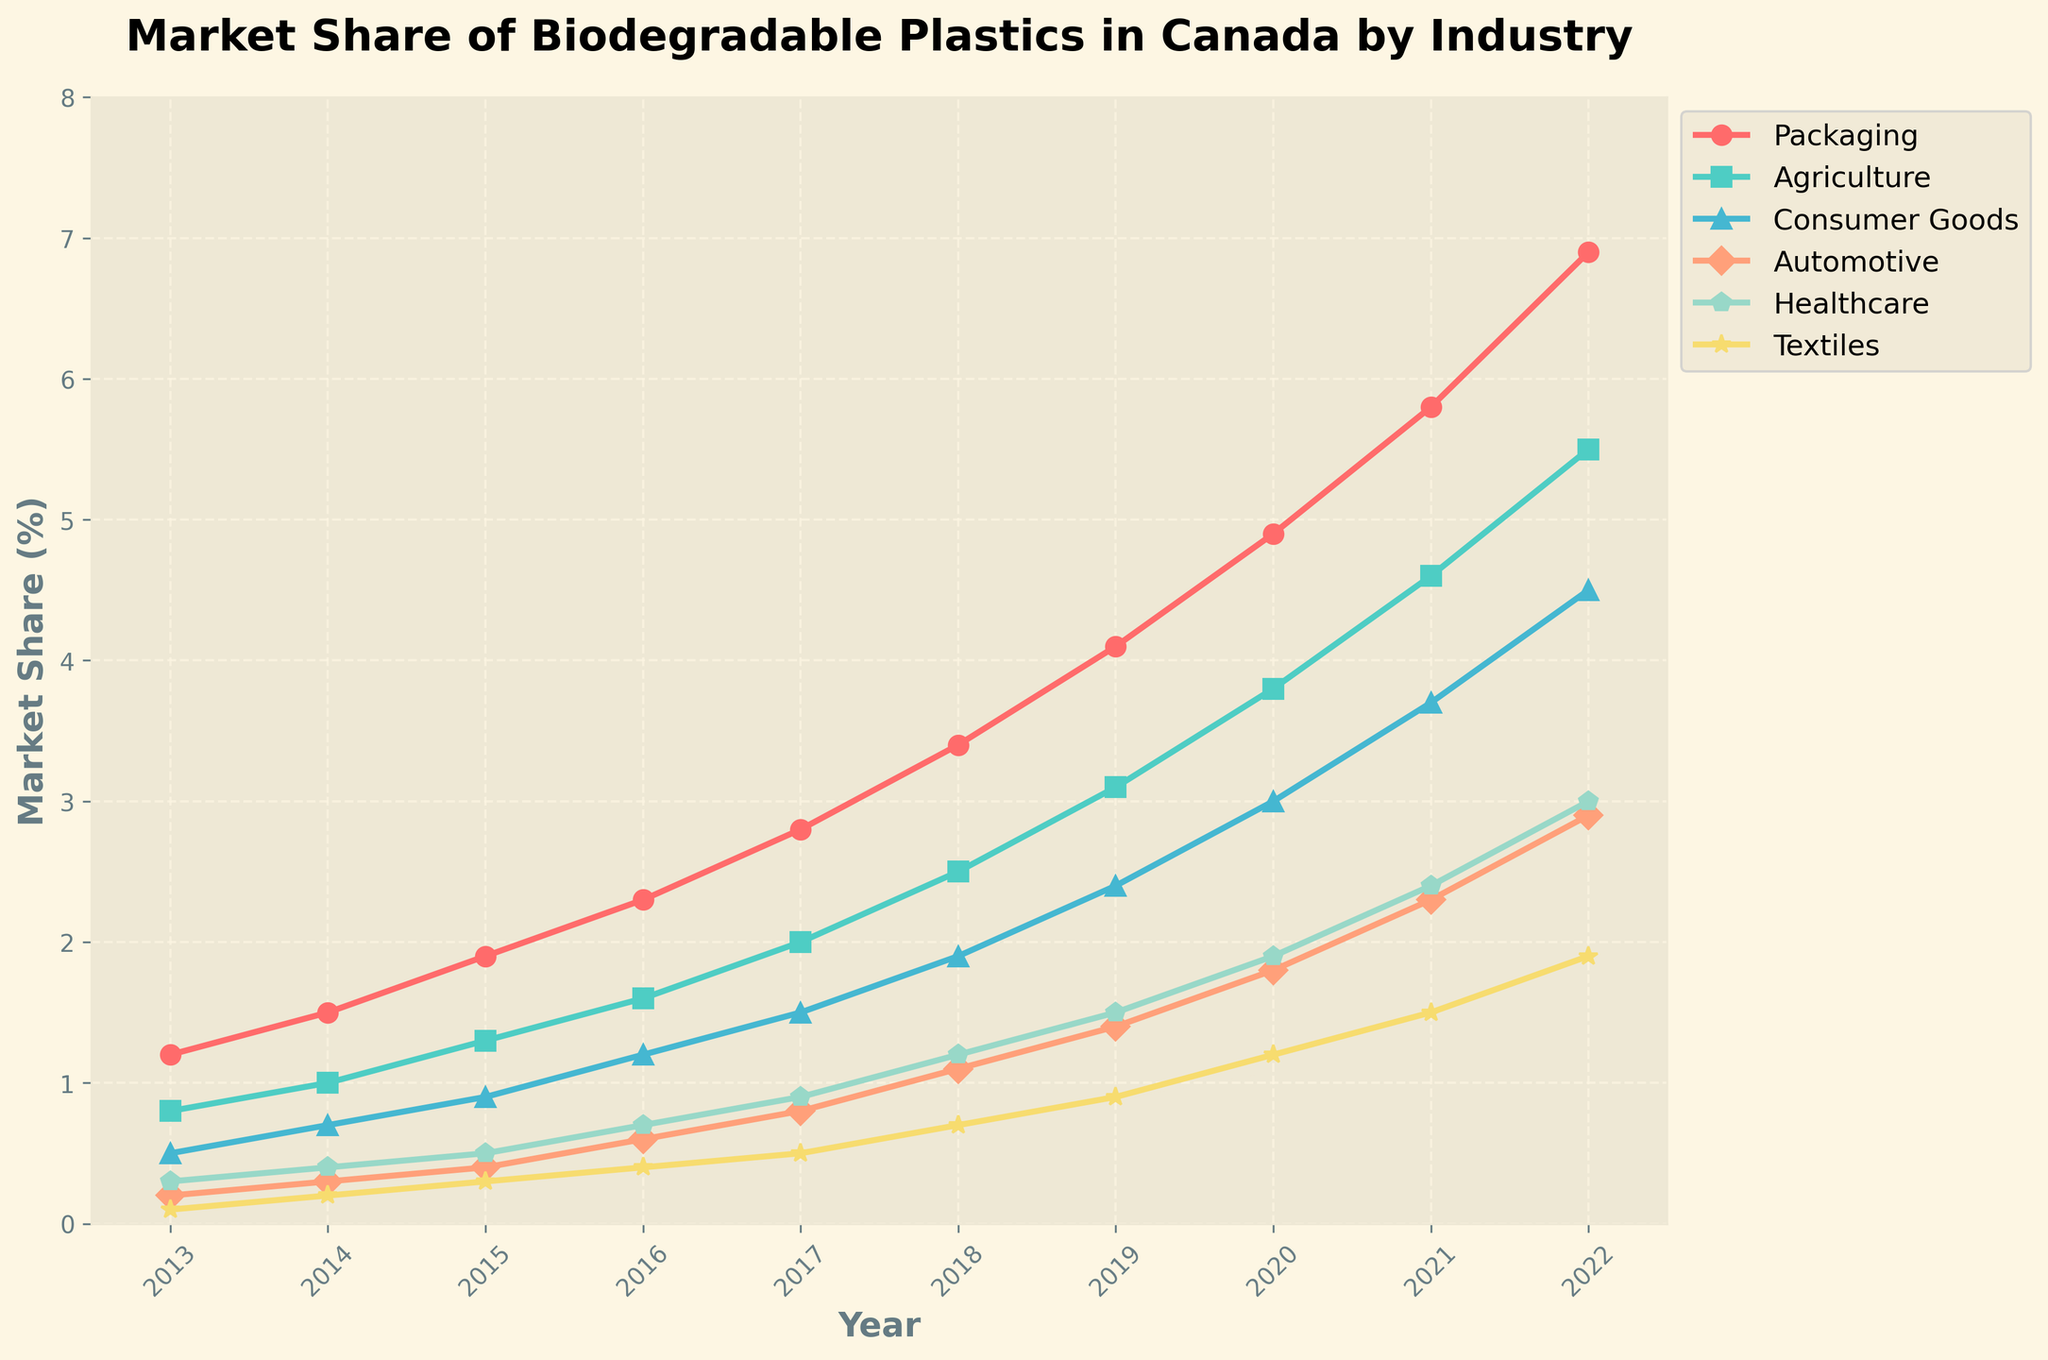Which year did the Packaging sector first surpass a 4.0% market share? Look for the year in the Packaging sector's line where the market share exceeds 4.0%. The data point above 4.0% shows up in 2019.
Answer: 2019 What is the difference in market share between the Packaging and Healthcare sectors in 2022? Subtract the market share of the Healthcare sector from the Packaging sector in 2022. 6.9 - 3.0 = 3.9
Answer: 3.9 How many industry sectors had a market share of at least 1.0% in 2016? Examine each sector's market share in 2016 to see if it is 1.0% or higher. Packaging, Agriculture, and Consumer Goods each have values higher than 1.0%.
Answer: 3 Which sector had the highest market share growth from 2013 to 2022? Calculate the increase for each sector from 2013 to 2022 (2022 value - 2013 value). Packaging increases by 6.9 - 1.2 = 5.7, Agriculture by 5.5 - 0.8 = 4.7, Consumer Goods by 4.5 - 0.5 = 4.0, Automotive by 2.9 - 0.2 = 2.7, Healthcare by 3.0 - 0.3 = 2.7, Textiles by 1.9 - 0.1 = 1.8. The Packaging sector has the highest growth.
Answer: Packaging Between Agriculture and Textiles, which sector had a higher market share in 2020? Compare the market share of Agriculture and Textiles in 2020. Agriculture has 3.8, while Textiles have 1.2.
Answer: Agriculture What is the average market share of the Consumer Goods sector between 2013 and 2022? Sum the Consumer Goods sector market shares over the years and divide by the number of years (10). (0.5 + 0.7 + 0.9 + 1.2 + 1.5 + 1.9 + 2.4 + 3.0 + 3.7 + 4.5) / 10 = 2.13.
Answer: 2.13 In which year did the Automotive sector's market share first reach 1.0%? Identify the year when the Automotive sector's market share reached or exceeded 1.0% for the first time. In 2018, the market share is 1.1%.
Answer: 2018 What was the total market share of all sectors combined in 2019? Sum the market shares of all sectors in 2019. 4.1 (Packaging) + 3.1 (Agriculture) + 2.4 (Consumer Goods) + 1.4 (Automotive) + 1.5 (Healthcare) + 0.9 (Textiles) = 13.4
Answer: 13.4 Which sector had the lowest market share in 2013? Review the market shares of all sectors in 2013 and identify the lowest one. Textiles had the lowest market share with 0.1.
Answer: Textiles What was the percentage increase in the market share of the Healthcare sector from 2015 to 2020? Calculate the increase and then the percentage increase from 2015 to 2020. Increase = 1.9 - 0.5 = 1.4, Percentage increase = (1.4 / 0.5) * 100 = 280%
Answer: 280% 